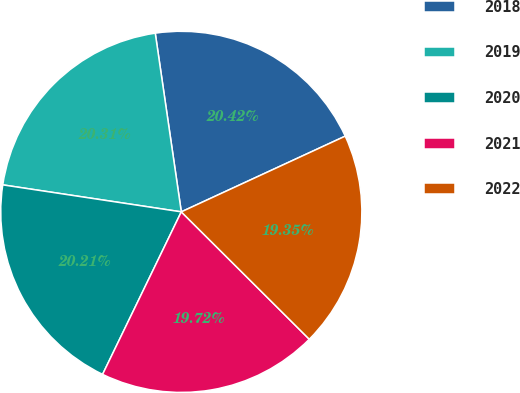<chart> <loc_0><loc_0><loc_500><loc_500><pie_chart><fcel>2018<fcel>2019<fcel>2020<fcel>2021<fcel>2022<nl><fcel>20.42%<fcel>20.31%<fcel>20.21%<fcel>19.72%<fcel>19.35%<nl></chart> 